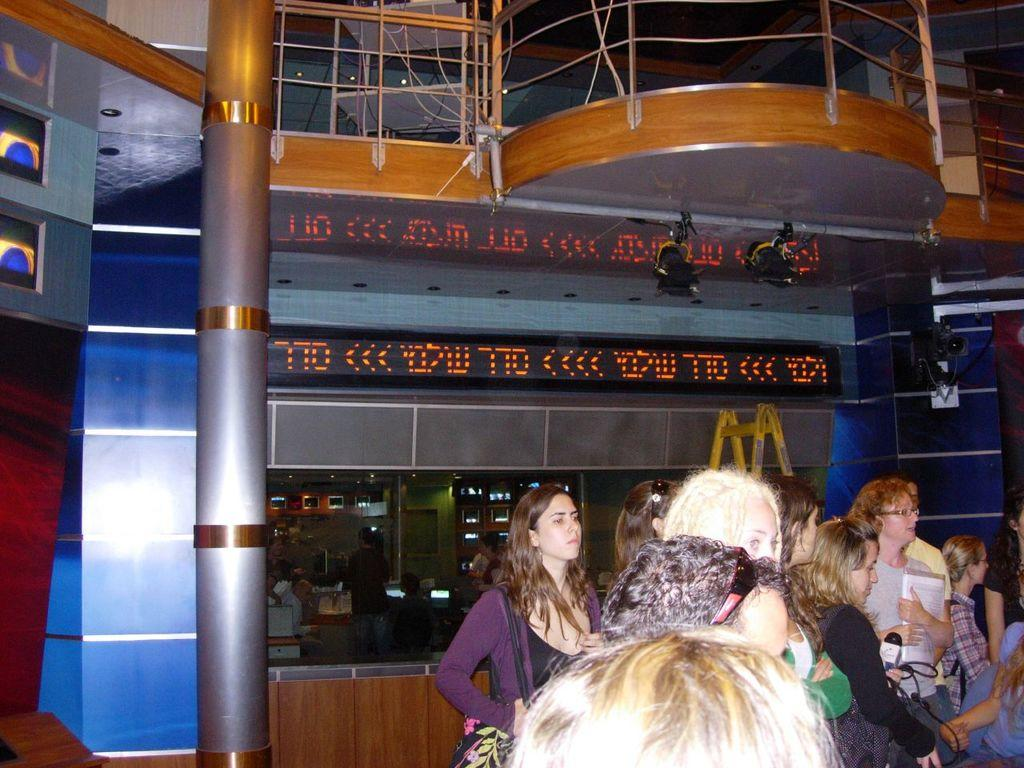What are the people in the image doing? The people in the image are standing on the surface. Can you describe what one person is holding in the image? One person is holding a microphone in the image. What type of screen is visible in the image? There is an LCD screen in the image. What kind of barrier is present in the image? There is a metal grill fence in the image. What type of gun is visible in the image? There is no gun present in the image. What type of jail can be seen in the image? There is no jail present in the image. 